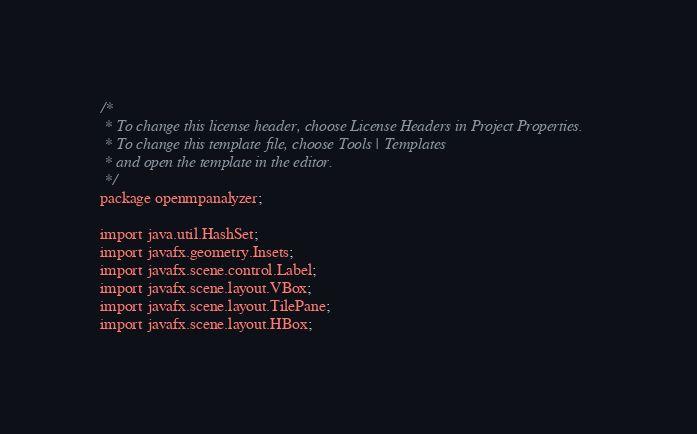<code> <loc_0><loc_0><loc_500><loc_500><_Java_>/*
 * To change this license header, choose License Headers in Project Properties.
 * To change this template file, choose Tools | Templates
 * and open the template in the editor.
 */
package openmpanalyzer;

import java.util.HashSet;
import javafx.geometry.Insets;
import javafx.scene.control.Label;
import javafx.scene.layout.VBox;
import javafx.scene.layout.TilePane;
import javafx.scene.layout.HBox;</code> 